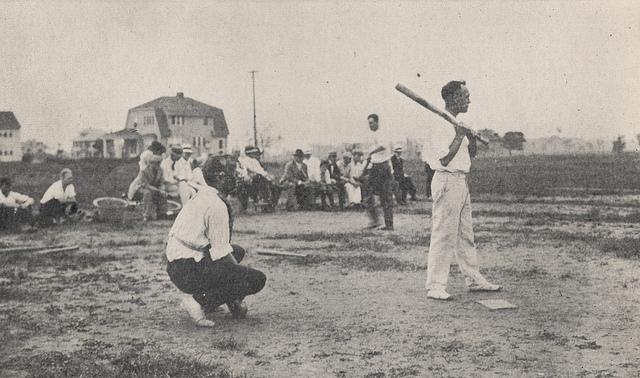Does it look like they had nice weather that day?
Quick response, please. Yes. How old do you think this picture is?
Short answer required. 1920. What is this man holding?
Short answer required. Bat. Where is the man at?
Give a very brief answer. Baseball field. Is this what they wore in old days to play ball?
Write a very short answer. Yes. 